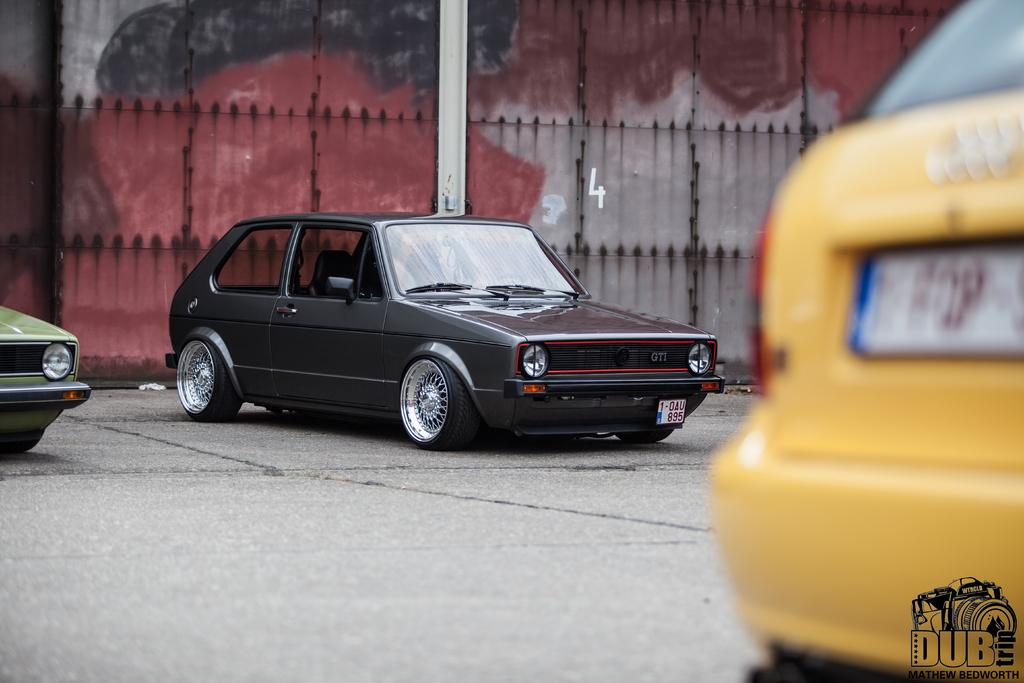<image>
Relay a brief, clear account of the picture shown. A picture of a few cars with a logo that says Dub in the corner. 